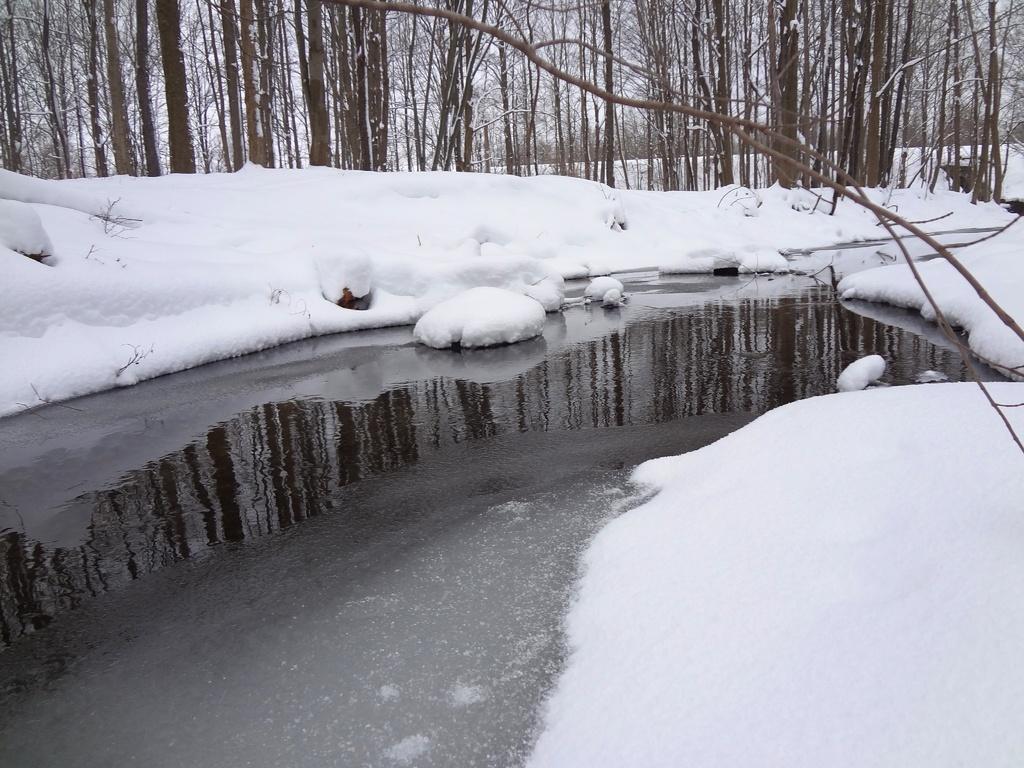Please provide a concise description of this image. In this picture I can see many trees and snow. In the bottom left corner I can see the water. 